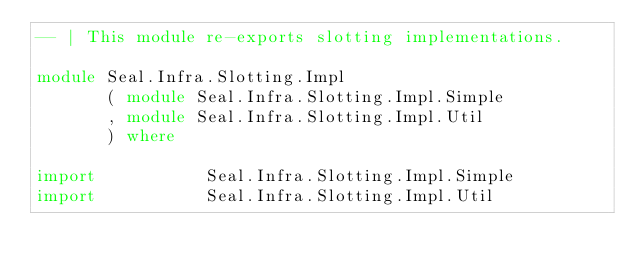<code> <loc_0><loc_0><loc_500><loc_500><_Haskell_>-- | This module re-exports slotting implementations.

module Seal.Infra.Slotting.Impl
       ( module Seal.Infra.Slotting.Impl.Simple
       , module Seal.Infra.Slotting.Impl.Util
       ) where

import           Seal.Infra.Slotting.Impl.Simple
import           Seal.Infra.Slotting.Impl.Util
</code> 